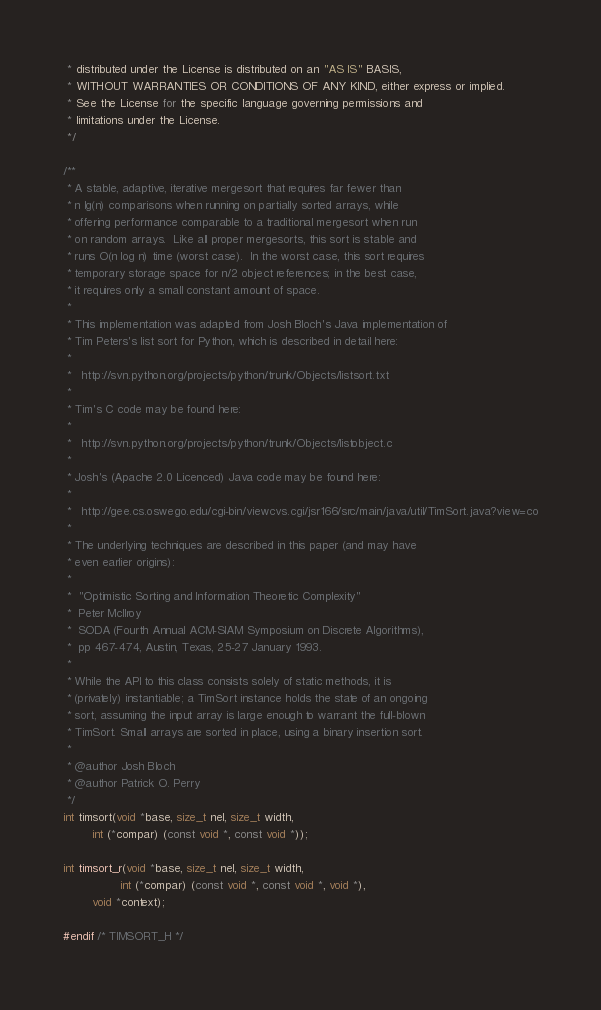<code> <loc_0><loc_0><loc_500><loc_500><_C_> * distributed under the License is distributed on an "AS IS" BASIS,
 * WITHOUT WARRANTIES OR CONDITIONS OF ANY KIND, either express or implied.
 * See the License for the specific language governing permissions and
 * limitations under the License.
 */

/**
 * A stable, adaptive, iterative mergesort that requires far fewer than
 * n lg(n) comparisons when running on partially sorted arrays, while
 * offering performance comparable to a traditional mergesort when run
 * on random arrays.  Like all proper mergesorts, this sort is stable and
 * runs O(n log n) time (worst case).  In the worst case, this sort requires
 * temporary storage space for n/2 object references; in the best case,
 * it requires only a small constant amount of space.
 *
 * This implementation was adapted from Josh Bloch's Java implementation of
 * Tim Peters's list sort for Python, which is described in detail here:
 *
 *   http://svn.python.org/projects/python/trunk/Objects/listsort.txt
 *
 * Tim's C code may be found here:
 *
 *   http://svn.python.org/projects/python/trunk/Objects/listobject.c
 *
 * Josh's (Apache 2.0 Licenced) Java code may be found here:
 *
 *   http://gee.cs.oswego.edu/cgi-bin/viewcvs.cgi/jsr166/src/main/java/util/TimSort.java?view=co
 *
 * The underlying techniques are described in this paper (and may have
 * even earlier origins):
 *
 *  "Optimistic Sorting and Information Theoretic Complexity"
 *  Peter McIlroy
 *  SODA (Fourth Annual ACM-SIAM Symposium on Discrete Algorithms),
 *  pp 467-474, Austin, Texas, 25-27 January 1993.
 *
 * While the API to this class consists solely of static methods, it is
 * (privately) instantiable; a TimSort instance holds the state of an ongoing
 * sort, assuming the input array is large enough to warrant the full-blown
 * TimSort. Small arrays are sorted in place, using a binary insertion sort.
 *
 * @author Josh Bloch
 * @author Patrick O. Perry
 */
int timsort(void *base, size_t nel, size_t width,
	    int (*compar) (const void *, const void *));

int timsort_r(void *base, size_t nel, size_t width,
                int (*compar) (const void *, const void *, void *),
		void *context);

#endif /* TIMSORT_H */</code> 